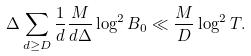<formula> <loc_0><loc_0><loc_500><loc_500>\Delta \sum _ { d \geq D } \frac { 1 } { d } \frac { M } { d \Delta } \log ^ { 2 } B _ { 0 } \ll \frac { M } { D } \log ^ { 2 } T .</formula> 